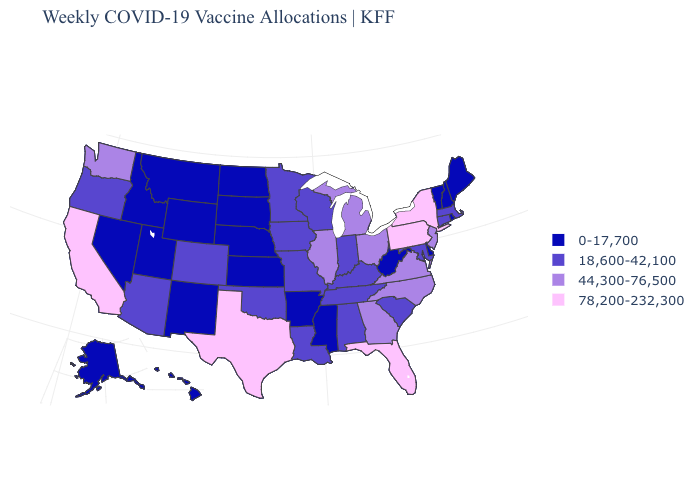Among the states that border Louisiana , which have the highest value?
Be succinct. Texas. How many symbols are there in the legend?
Write a very short answer. 4. Name the states that have a value in the range 78,200-232,300?
Be succinct. California, Florida, New York, Pennsylvania, Texas. Name the states that have a value in the range 78,200-232,300?
Write a very short answer. California, Florida, New York, Pennsylvania, Texas. Which states have the highest value in the USA?
Be succinct. California, Florida, New York, Pennsylvania, Texas. Which states have the lowest value in the Northeast?
Short answer required. Maine, New Hampshire, Rhode Island, Vermont. Does Missouri have the highest value in the MidWest?
Quick response, please. No. Name the states that have a value in the range 18,600-42,100?
Keep it brief. Alabama, Arizona, Colorado, Connecticut, Indiana, Iowa, Kentucky, Louisiana, Maryland, Massachusetts, Minnesota, Missouri, Oklahoma, Oregon, South Carolina, Tennessee, Wisconsin. Does Oklahoma have the highest value in the South?
Give a very brief answer. No. Name the states that have a value in the range 78,200-232,300?
Keep it brief. California, Florida, New York, Pennsylvania, Texas. What is the value of Connecticut?
Short answer required. 18,600-42,100. Does Kentucky have the same value as Florida?
Keep it brief. No. How many symbols are there in the legend?
Concise answer only. 4. Among the states that border Oregon , does California have the lowest value?
Be succinct. No. Which states have the lowest value in the Northeast?
Write a very short answer. Maine, New Hampshire, Rhode Island, Vermont. 